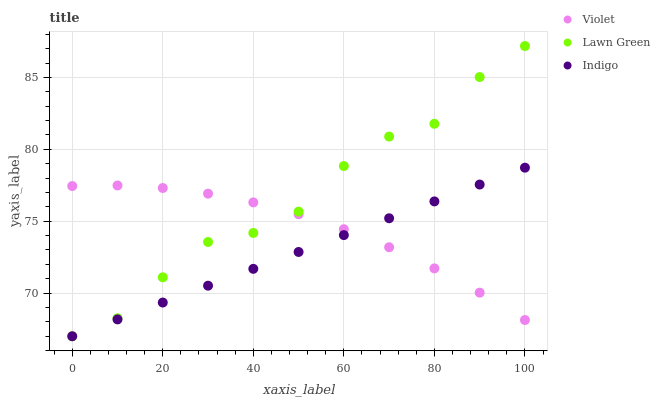Does Indigo have the minimum area under the curve?
Answer yes or no. Yes. Does Lawn Green have the maximum area under the curve?
Answer yes or no. Yes. Does Violet have the minimum area under the curve?
Answer yes or no. No. Does Violet have the maximum area under the curve?
Answer yes or no. No. Is Indigo the smoothest?
Answer yes or no. Yes. Is Lawn Green the roughest?
Answer yes or no. Yes. Is Violet the smoothest?
Answer yes or no. No. Is Violet the roughest?
Answer yes or no. No. Does Lawn Green have the lowest value?
Answer yes or no. Yes. Does Violet have the lowest value?
Answer yes or no. No. Does Lawn Green have the highest value?
Answer yes or no. Yes. Does Indigo have the highest value?
Answer yes or no. No. Does Lawn Green intersect Violet?
Answer yes or no. Yes. Is Lawn Green less than Violet?
Answer yes or no. No. Is Lawn Green greater than Violet?
Answer yes or no. No. 